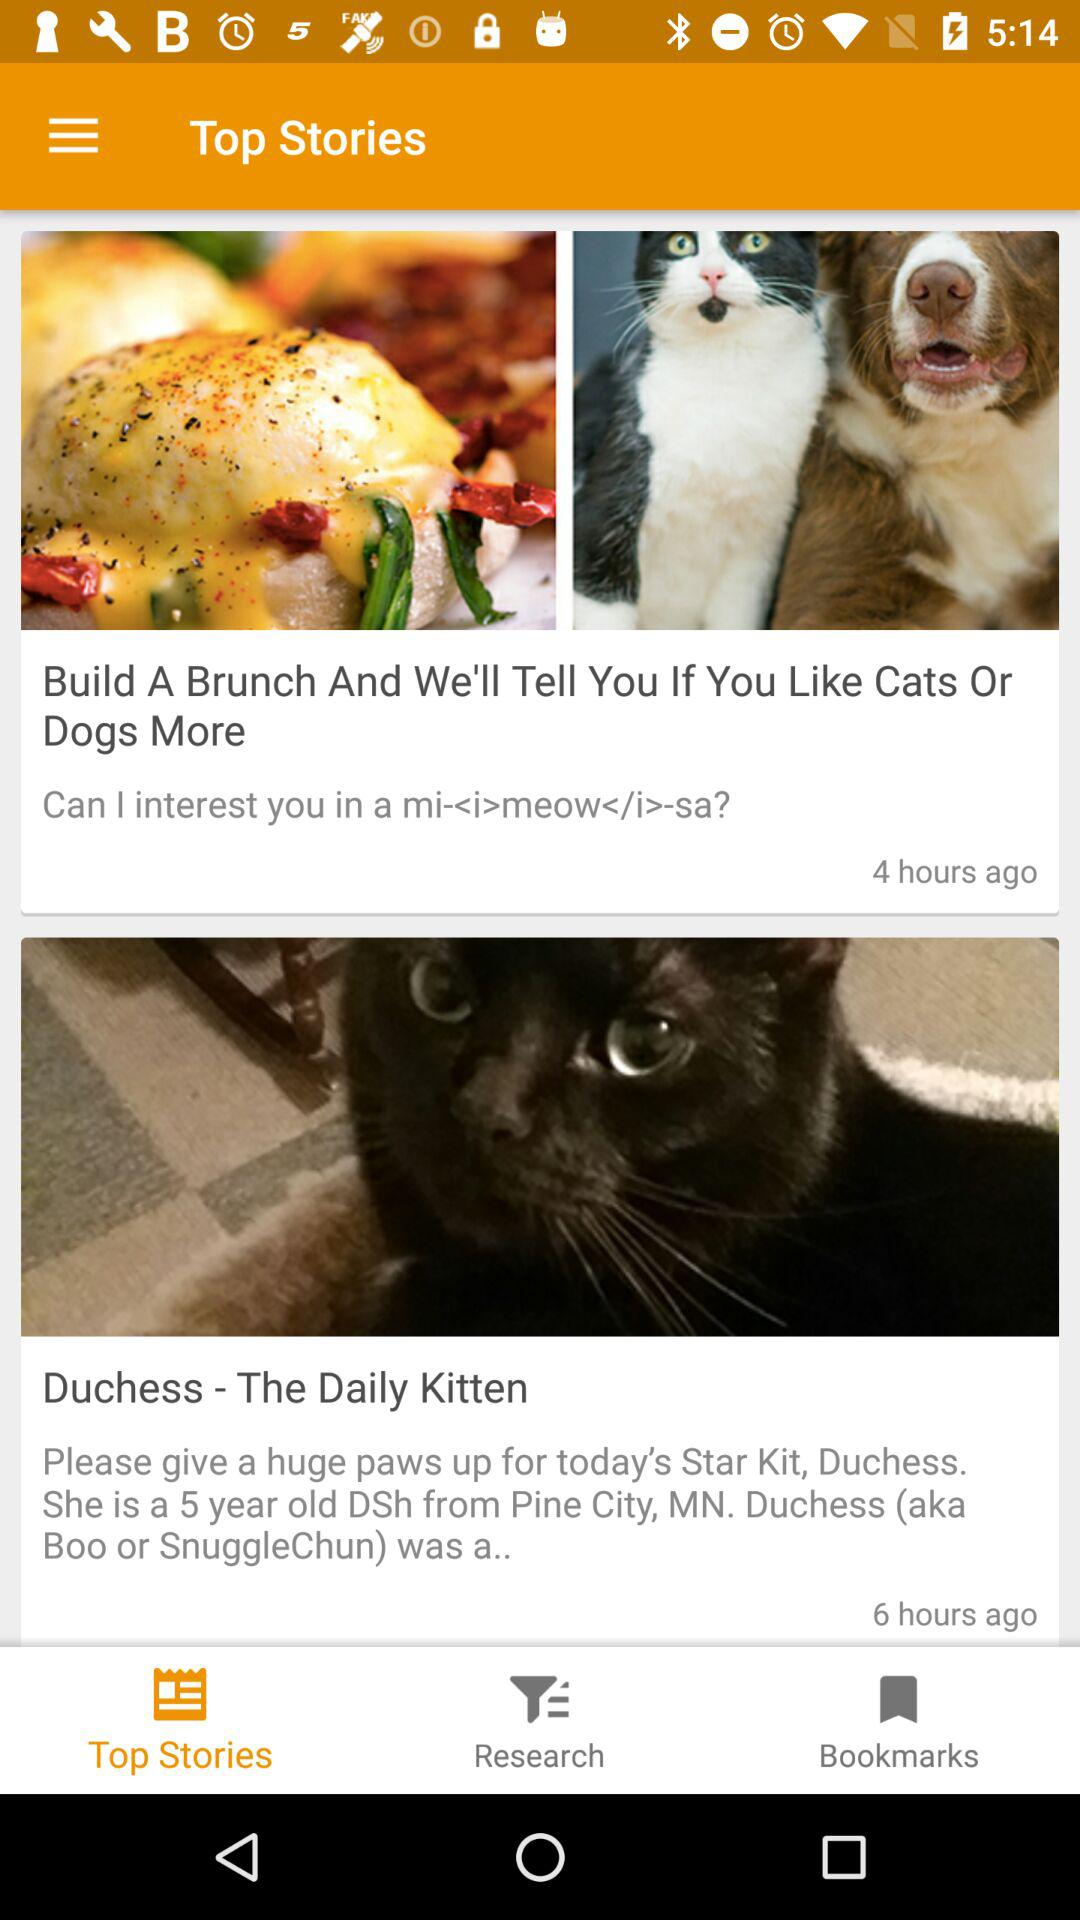Which tab is selected? The selected tab is "Top Stories". 